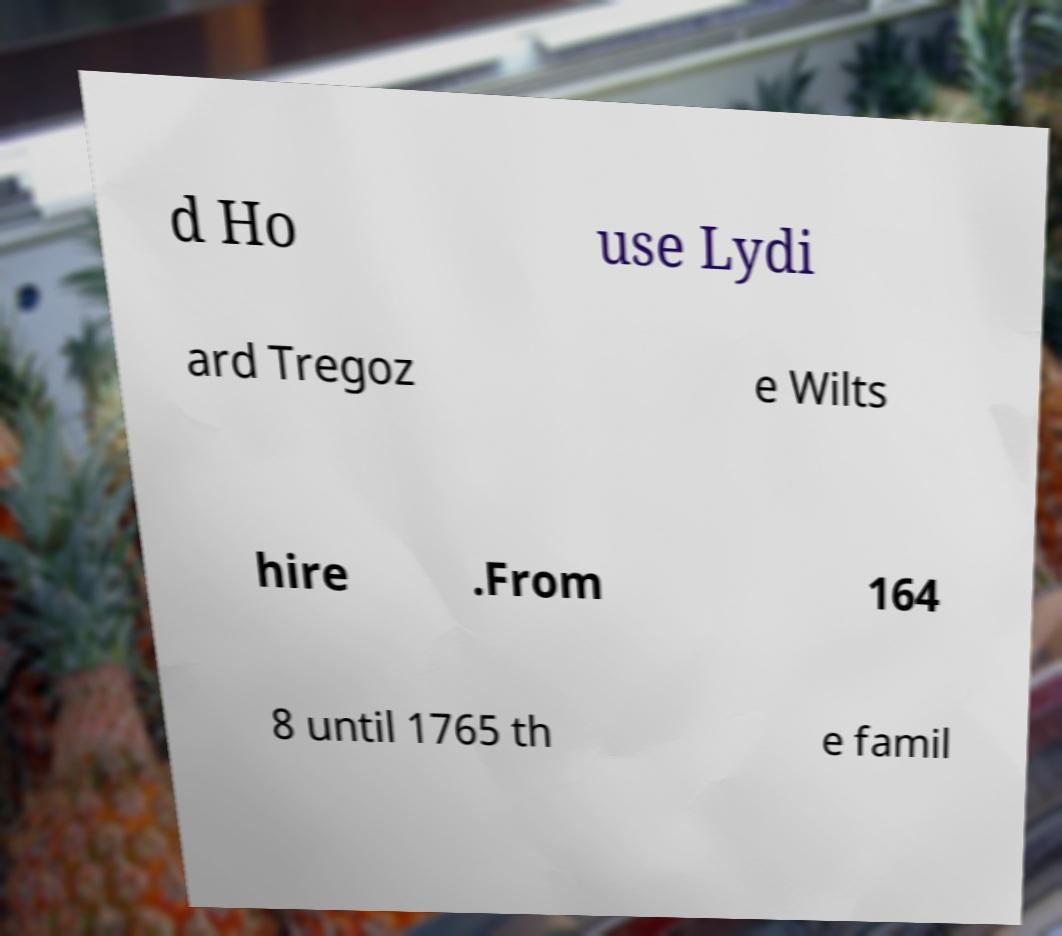Please read and relay the text visible in this image. What does it say? d Ho use Lydi ard Tregoz e Wilts hire .From 164 8 until 1765 th e famil 